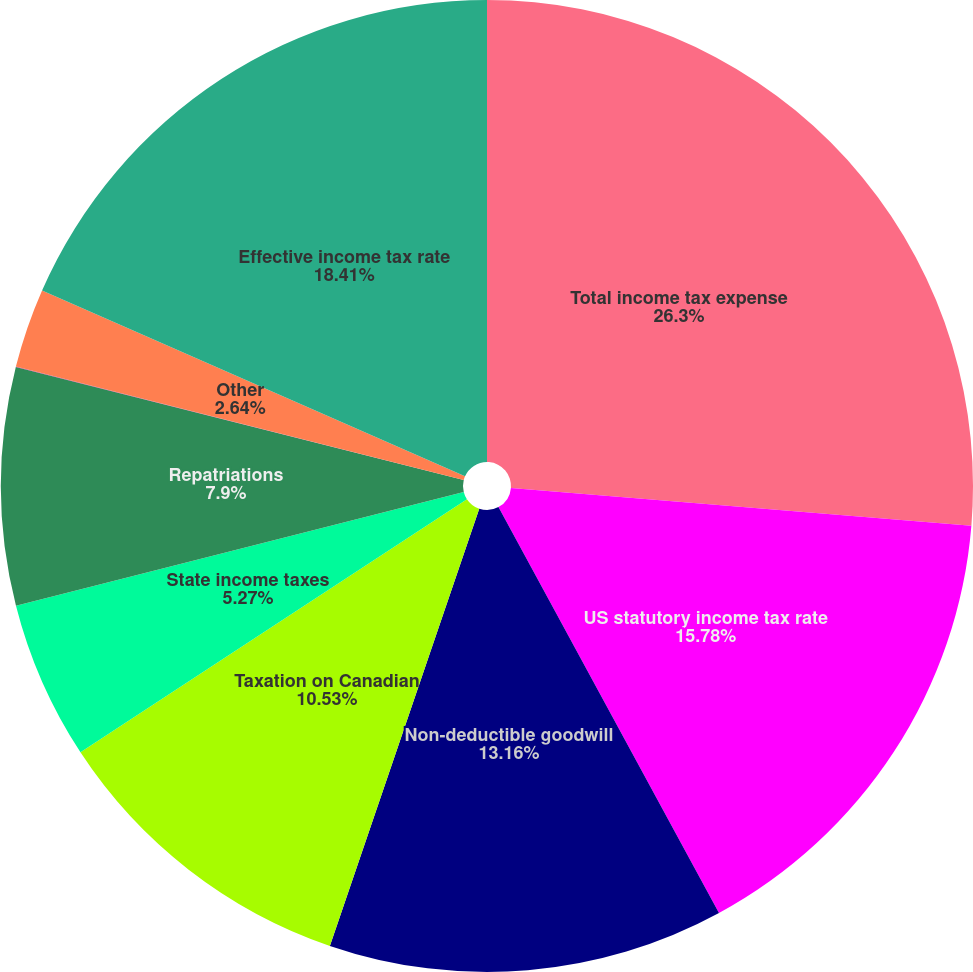<chart> <loc_0><loc_0><loc_500><loc_500><pie_chart><fcel>Total income tax expense<fcel>US statutory income tax rate<fcel>Non-deductible goodwill<fcel>Taxation on Canadian<fcel>State income taxes<fcel>Repatriations<fcel>Taxes on EnLink formation<fcel>Other<fcel>Effective income tax rate<nl><fcel>26.3%<fcel>15.78%<fcel>13.16%<fcel>10.53%<fcel>5.27%<fcel>7.9%<fcel>0.01%<fcel>2.64%<fcel>18.41%<nl></chart> 